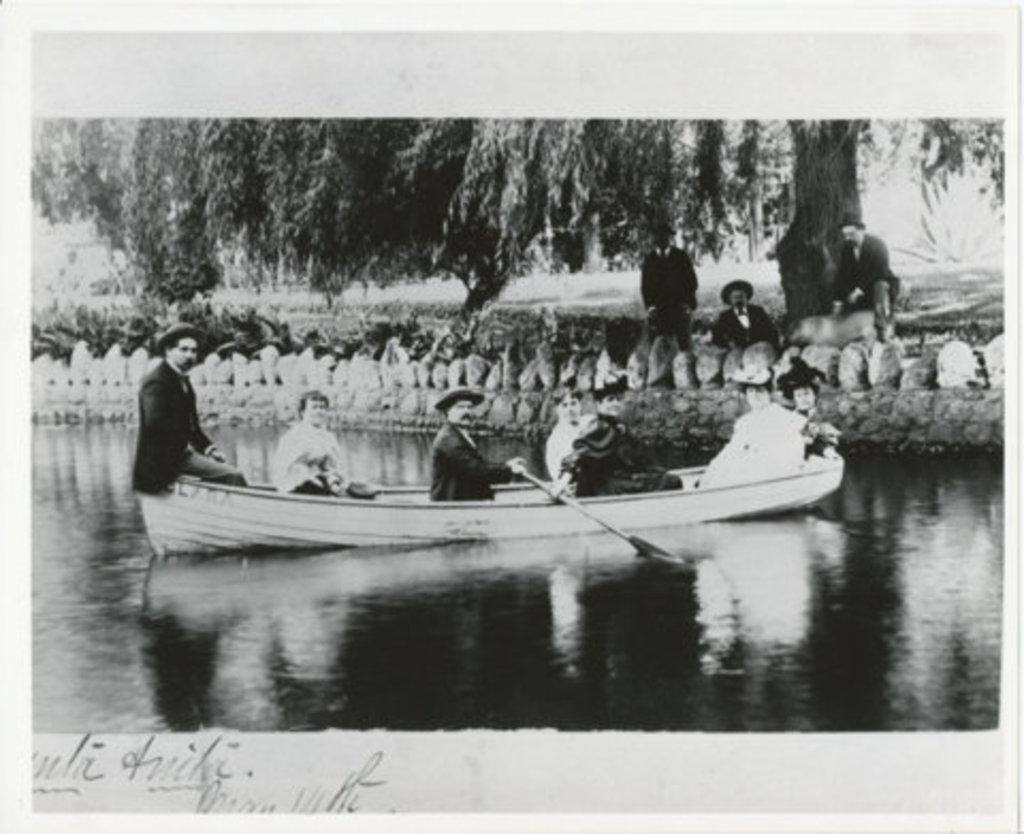What is the color scheme of the image? The image is black and white. What activity are the people in the image engaged in? There is a group of people in a boat in the image. Where is the boat located? The boat is on a river. What can be seen in the background of the image? There is a huge tree in the background. How many people are under the tree? There are three people under the tree. What is the weight of the ant on the boat in the image? There is no ant present on the boat in the image, so it is not possible to determine its weight. 